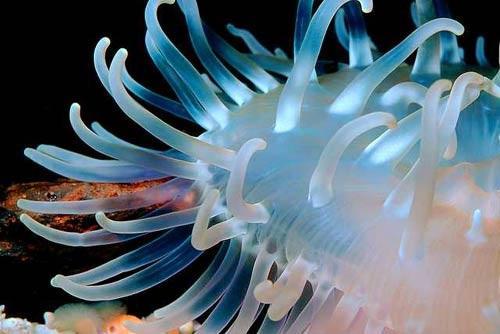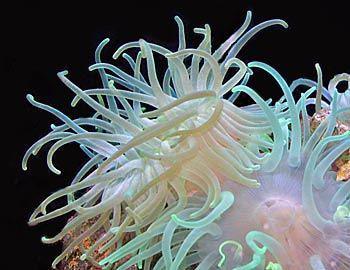The first image is the image on the left, the second image is the image on the right. For the images displayed, is the sentence "One image features a single jellyfish with spiky, non-rounded tendrils that are two-toned in white and another color." factually correct? Answer yes or no. No. 